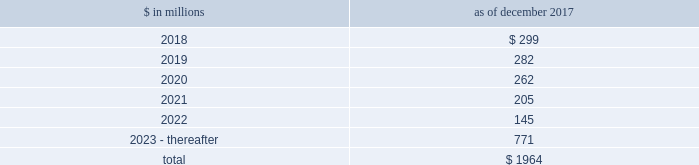The goldman sachs group , inc .
And subsidiaries notes to consolidated financial statements commercial lending .
The firm 2019s commercial lending commitments are extended to investment-grade and non-investment-grade corporate borrowers .
Commitments to investment-grade corporate borrowers are principally used for operating liquidity and general corporate purposes .
The firm also extends lending commitments in connection with contingent acquisition financing and other types of corporate lending , as well as commercial real estate financing .
Commitments that are extended for contingent acquisition financing are often intended to be short-term in nature , as borrowers often seek to replace them with other funding sources .
Sumitomo mitsui financial group , inc .
( smfg ) provides the firm with credit loss protection on certain approved loan commitments ( primarily investment-grade commercial lending commitments ) .
The notional amount of such loan commitments was $ 25.70 billion and $ 26.88 billion as of december 2017 and december 2016 , respectively .
The credit loss protection on loan commitments provided by smfg is generally limited to 95% ( 95 % ) of the first loss the firm realizes on such commitments , up to a maximum of approximately $ 950 million .
In addition , subject to the satisfaction of certain conditions , upon the firm 2019s request , smfg will provide protection for 70% ( 70 % ) of additional losses on such commitments , up to a maximum of $ 1.13 billion , of which $ 550 million and $ 768 million of protection had been provided as of december 2017 and december 2016 , respectively .
The firm also uses other financial instruments to mitigate credit risks related to certain commitments not covered by smfg .
These instruments primarily include credit default swaps that reference the same or similar underlying instrument or entity , or credit default swaps that reference a market index .
Warehouse financing .
The firm provides financing to clients who warehouse financial assets .
These arrangements are secured by the warehoused assets , primarily consisting of retail and corporate loans .
Contingent and forward starting collateralized agreements / forward starting collateralized financings contingent and forward starting collateralized agreements includes resale and securities borrowing agreements , and forward starting collateralized financings includes repurchase and secured lending agreements that settle at a future date , generally within three business days .
The firm also enters into commitments to provide contingent financing to its clients and counterparties through resale agreements .
The firm 2019s funding of these commitments depends on the satisfaction of all contractual conditions to the resale agreement and these commitments can expire unused .
Letters of credit the firm has commitments under letters of credit issued by various banks which the firm provides to counterparties in lieu of securities or cash to satisfy various collateral and margin deposit requirements .
Investment commitments investment commitments includes commitments to invest in private equity , real estate and other assets directly and through funds that the firm raises and manages .
Investment commitments included $ 2.09 billion and $ 2.10 billion as of december 2017 and december 2016 , respectively , related to commitments to invest in funds managed by the firm .
If these commitments are called , they would be funded at market value on the date of investment .
Leases the firm has contractual obligations under long-term noncancelable lease agreements for office space expiring on various dates through 2069 .
Certain agreements are subject to periodic escalation provisions for increases in real estate taxes and other charges .
The table below presents future minimum rental payments , net of minimum sublease rentals .
$ in millions december 2017 .
Rent charged to operating expenses was $ 273 million for 2017 , $ 244 million for 2016 and $ 249 million for 2015 .
Goldman sachs 2017 form 10-k 163 .
Minimum rents due in 2023 - thereafter are what percent of total future minimum rental payments?\\n? 
Computations: (771 / 1964)
Answer: 0.39257. 